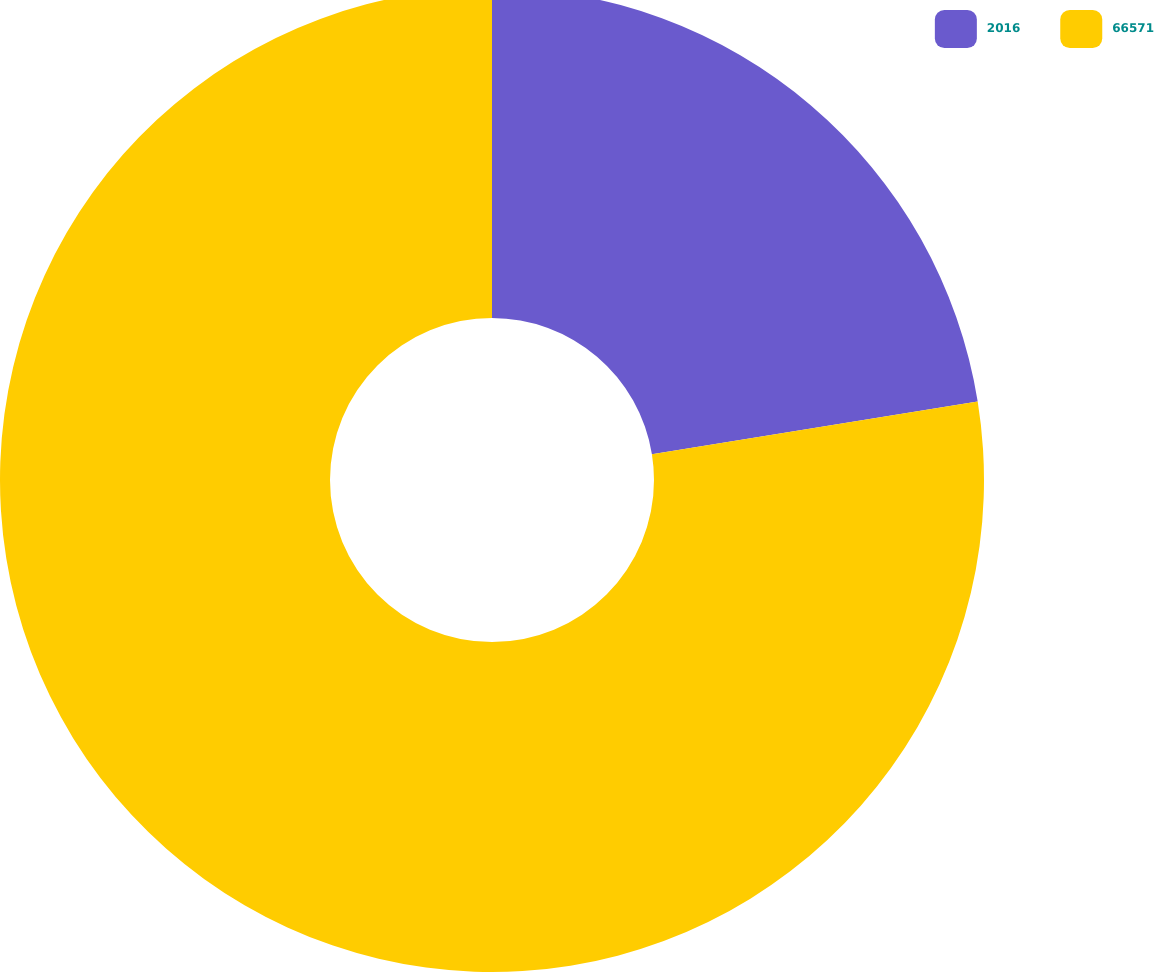Convert chart to OTSL. <chart><loc_0><loc_0><loc_500><loc_500><pie_chart><fcel>2016<fcel>66571<nl><fcel>22.45%<fcel>77.55%<nl></chart> 